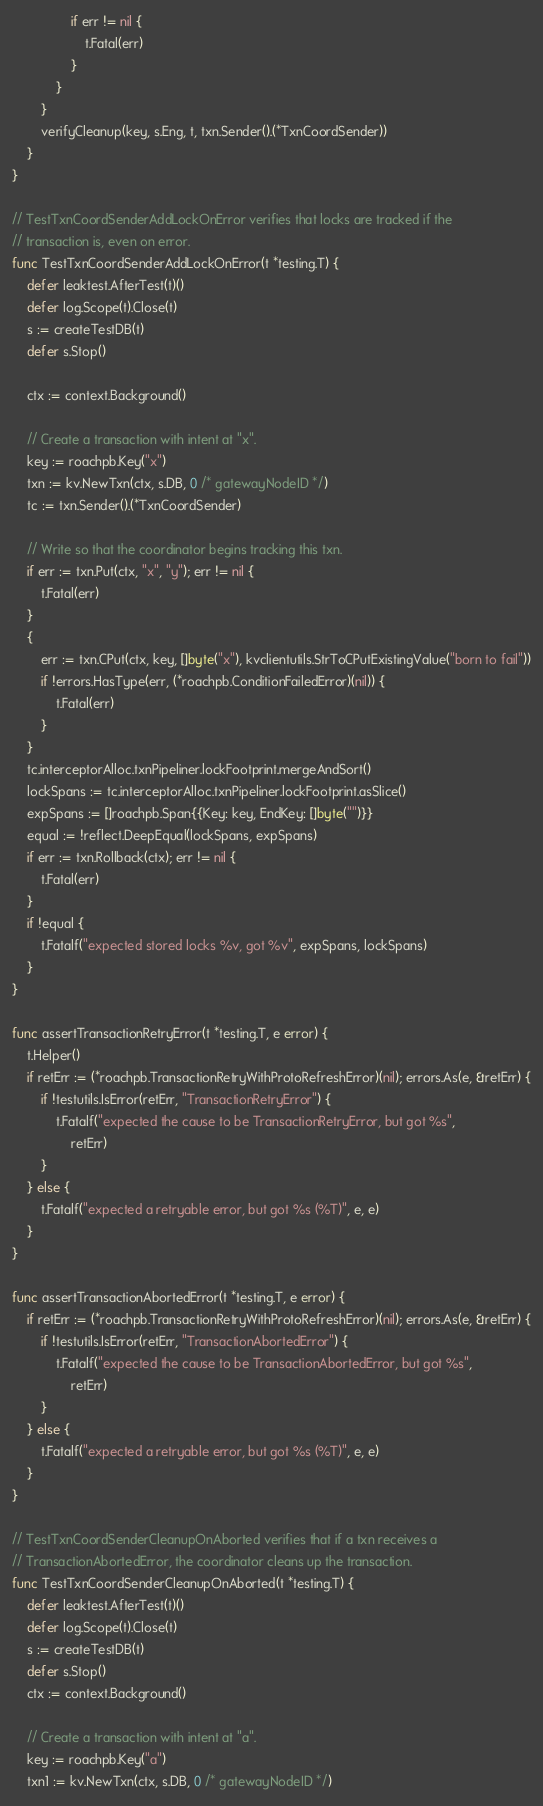Convert code to text. <code><loc_0><loc_0><loc_500><loc_500><_Go_>				if err != nil {
					t.Fatal(err)
				}
			}
		}
		verifyCleanup(key, s.Eng, t, txn.Sender().(*TxnCoordSender))
	}
}

// TestTxnCoordSenderAddLockOnError verifies that locks are tracked if the
// transaction is, even on error.
func TestTxnCoordSenderAddLockOnError(t *testing.T) {
	defer leaktest.AfterTest(t)()
	defer log.Scope(t).Close(t)
	s := createTestDB(t)
	defer s.Stop()

	ctx := context.Background()

	// Create a transaction with intent at "x".
	key := roachpb.Key("x")
	txn := kv.NewTxn(ctx, s.DB, 0 /* gatewayNodeID */)
	tc := txn.Sender().(*TxnCoordSender)

	// Write so that the coordinator begins tracking this txn.
	if err := txn.Put(ctx, "x", "y"); err != nil {
		t.Fatal(err)
	}
	{
		err := txn.CPut(ctx, key, []byte("x"), kvclientutils.StrToCPutExistingValue("born to fail"))
		if !errors.HasType(err, (*roachpb.ConditionFailedError)(nil)) {
			t.Fatal(err)
		}
	}
	tc.interceptorAlloc.txnPipeliner.lockFootprint.mergeAndSort()
	lockSpans := tc.interceptorAlloc.txnPipeliner.lockFootprint.asSlice()
	expSpans := []roachpb.Span{{Key: key, EndKey: []byte("")}}
	equal := !reflect.DeepEqual(lockSpans, expSpans)
	if err := txn.Rollback(ctx); err != nil {
		t.Fatal(err)
	}
	if !equal {
		t.Fatalf("expected stored locks %v, got %v", expSpans, lockSpans)
	}
}

func assertTransactionRetryError(t *testing.T, e error) {
	t.Helper()
	if retErr := (*roachpb.TransactionRetryWithProtoRefreshError)(nil); errors.As(e, &retErr) {
		if !testutils.IsError(retErr, "TransactionRetryError") {
			t.Fatalf("expected the cause to be TransactionRetryError, but got %s",
				retErr)
		}
	} else {
		t.Fatalf("expected a retryable error, but got %s (%T)", e, e)
	}
}

func assertTransactionAbortedError(t *testing.T, e error) {
	if retErr := (*roachpb.TransactionRetryWithProtoRefreshError)(nil); errors.As(e, &retErr) {
		if !testutils.IsError(retErr, "TransactionAbortedError") {
			t.Fatalf("expected the cause to be TransactionAbortedError, but got %s",
				retErr)
		}
	} else {
		t.Fatalf("expected a retryable error, but got %s (%T)", e, e)
	}
}

// TestTxnCoordSenderCleanupOnAborted verifies that if a txn receives a
// TransactionAbortedError, the coordinator cleans up the transaction.
func TestTxnCoordSenderCleanupOnAborted(t *testing.T) {
	defer leaktest.AfterTest(t)()
	defer log.Scope(t).Close(t)
	s := createTestDB(t)
	defer s.Stop()
	ctx := context.Background()

	// Create a transaction with intent at "a".
	key := roachpb.Key("a")
	txn1 := kv.NewTxn(ctx, s.DB, 0 /* gatewayNodeID */)</code> 